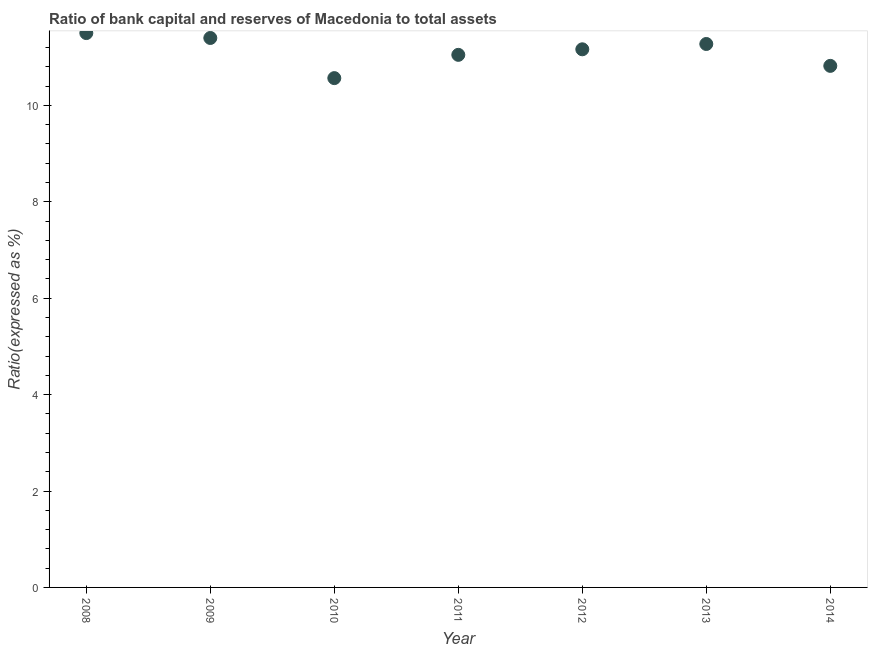What is the bank capital to assets ratio in 2014?
Make the answer very short. 10.82. Across all years, what is the maximum bank capital to assets ratio?
Make the answer very short. 11.5. Across all years, what is the minimum bank capital to assets ratio?
Offer a terse response. 10.57. In which year was the bank capital to assets ratio maximum?
Ensure brevity in your answer.  2008. What is the sum of the bank capital to assets ratio?
Provide a succinct answer. 77.77. What is the difference between the bank capital to assets ratio in 2008 and 2011?
Ensure brevity in your answer.  0.45. What is the average bank capital to assets ratio per year?
Offer a terse response. 11.11. What is the median bank capital to assets ratio?
Keep it short and to the point. 11.16. Do a majority of the years between 2011 and 2014 (inclusive) have bank capital to assets ratio greater than 9.6 %?
Provide a succinct answer. Yes. What is the ratio of the bank capital to assets ratio in 2013 to that in 2014?
Your answer should be compact. 1.04. Is the difference between the bank capital to assets ratio in 2011 and 2013 greater than the difference between any two years?
Your answer should be very brief. No. What is the difference between the highest and the second highest bank capital to assets ratio?
Offer a very short reply. 0.1. What is the difference between the highest and the lowest bank capital to assets ratio?
Provide a succinct answer. 0.93. What is the difference between two consecutive major ticks on the Y-axis?
Provide a succinct answer. 2. What is the title of the graph?
Your answer should be very brief. Ratio of bank capital and reserves of Macedonia to total assets. What is the label or title of the Y-axis?
Keep it short and to the point. Ratio(expressed as %). What is the Ratio(expressed as %) in 2009?
Offer a very short reply. 11.4. What is the Ratio(expressed as %) in 2010?
Keep it short and to the point. 10.57. What is the Ratio(expressed as %) in 2011?
Give a very brief answer. 11.05. What is the Ratio(expressed as %) in 2012?
Offer a terse response. 11.16. What is the Ratio(expressed as %) in 2013?
Your answer should be compact. 11.27. What is the Ratio(expressed as %) in 2014?
Offer a terse response. 10.82. What is the difference between the Ratio(expressed as %) in 2008 and 2009?
Provide a short and direct response. 0.1. What is the difference between the Ratio(expressed as %) in 2008 and 2010?
Your answer should be very brief. 0.93. What is the difference between the Ratio(expressed as %) in 2008 and 2011?
Make the answer very short. 0.45. What is the difference between the Ratio(expressed as %) in 2008 and 2012?
Provide a succinct answer. 0.34. What is the difference between the Ratio(expressed as %) in 2008 and 2013?
Keep it short and to the point. 0.23. What is the difference between the Ratio(expressed as %) in 2008 and 2014?
Give a very brief answer. 0.68. What is the difference between the Ratio(expressed as %) in 2009 and 2010?
Give a very brief answer. 0.83. What is the difference between the Ratio(expressed as %) in 2009 and 2011?
Your answer should be very brief. 0.35. What is the difference between the Ratio(expressed as %) in 2009 and 2012?
Give a very brief answer. 0.23. What is the difference between the Ratio(expressed as %) in 2009 and 2013?
Your answer should be compact. 0.12. What is the difference between the Ratio(expressed as %) in 2009 and 2014?
Provide a short and direct response. 0.58. What is the difference between the Ratio(expressed as %) in 2010 and 2011?
Make the answer very short. -0.48. What is the difference between the Ratio(expressed as %) in 2010 and 2012?
Make the answer very short. -0.6. What is the difference between the Ratio(expressed as %) in 2010 and 2013?
Provide a short and direct response. -0.71. What is the difference between the Ratio(expressed as %) in 2010 and 2014?
Your response must be concise. -0.25. What is the difference between the Ratio(expressed as %) in 2011 and 2012?
Offer a terse response. -0.11. What is the difference between the Ratio(expressed as %) in 2011 and 2013?
Give a very brief answer. -0.23. What is the difference between the Ratio(expressed as %) in 2011 and 2014?
Your response must be concise. 0.23. What is the difference between the Ratio(expressed as %) in 2012 and 2013?
Offer a very short reply. -0.11. What is the difference between the Ratio(expressed as %) in 2012 and 2014?
Offer a terse response. 0.34. What is the difference between the Ratio(expressed as %) in 2013 and 2014?
Give a very brief answer. 0.45. What is the ratio of the Ratio(expressed as %) in 2008 to that in 2009?
Provide a succinct answer. 1.01. What is the ratio of the Ratio(expressed as %) in 2008 to that in 2010?
Your answer should be compact. 1.09. What is the ratio of the Ratio(expressed as %) in 2008 to that in 2011?
Give a very brief answer. 1.04. What is the ratio of the Ratio(expressed as %) in 2008 to that in 2013?
Your answer should be compact. 1.02. What is the ratio of the Ratio(expressed as %) in 2008 to that in 2014?
Keep it short and to the point. 1.06. What is the ratio of the Ratio(expressed as %) in 2009 to that in 2010?
Ensure brevity in your answer.  1.08. What is the ratio of the Ratio(expressed as %) in 2009 to that in 2011?
Your response must be concise. 1.03. What is the ratio of the Ratio(expressed as %) in 2009 to that in 2013?
Your answer should be compact. 1.01. What is the ratio of the Ratio(expressed as %) in 2009 to that in 2014?
Ensure brevity in your answer.  1.05. What is the ratio of the Ratio(expressed as %) in 2010 to that in 2011?
Make the answer very short. 0.96. What is the ratio of the Ratio(expressed as %) in 2010 to that in 2012?
Keep it short and to the point. 0.95. What is the ratio of the Ratio(expressed as %) in 2010 to that in 2013?
Offer a terse response. 0.94. What is the ratio of the Ratio(expressed as %) in 2010 to that in 2014?
Ensure brevity in your answer.  0.98. What is the ratio of the Ratio(expressed as %) in 2011 to that in 2013?
Your answer should be very brief. 0.98. What is the ratio of the Ratio(expressed as %) in 2012 to that in 2013?
Offer a terse response. 0.99. What is the ratio of the Ratio(expressed as %) in 2012 to that in 2014?
Your response must be concise. 1.03. What is the ratio of the Ratio(expressed as %) in 2013 to that in 2014?
Provide a succinct answer. 1.04. 